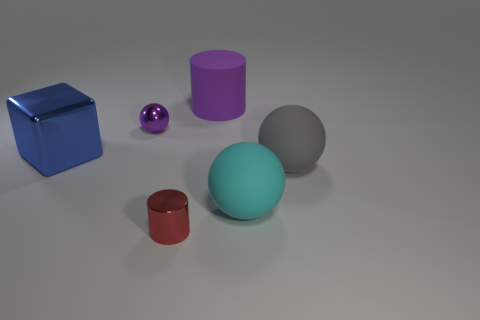Subtract all tiny purple spheres. How many spheres are left? 2 Add 4 big yellow cubes. How many objects exist? 10 Subtract all purple balls. How many balls are left? 2 Subtract 2 spheres. How many spheres are left? 1 Subtract all cylinders. How many objects are left? 4 Subtract all brown cylinders. Subtract all cyan cubes. How many cylinders are left? 2 Subtract all red spheres. How many green cubes are left? 0 Subtract all big gray blocks. Subtract all big gray rubber balls. How many objects are left? 5 Add 6 big blue metallic objects. How many big blue metallic objects are left? 7 Add 6 red metal blocks. How many red metal blocks exist? 6 